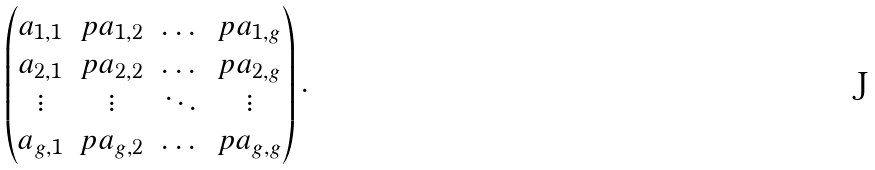<formula> <loc_0><loc_0><loc_500><loc_500>\begin{pmatrix} a _ { 1 , 1 } & p a _ { 1 , 2 } & \dots & p a _ { 1 , g } \\ a _ { 2 , 1 } & p a _ { 2 , 2 } & \dots & p a _ { 2 , g } \\ \vdots & \vdots & \ddots & \vdots \\ a _ { g , 1 } & p a _ { g , 2 } & \dots & p a _ { g , g } \end{pmatrix} .</formula> 